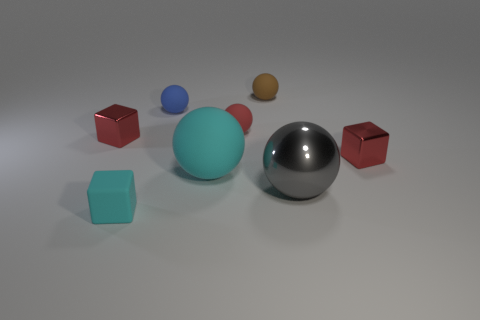How many things are both behind the red ball and in front of the big gray sphere?
Provide a succinct answer. 0. How many matte objects are tiny things or small brown things?
Ensure brevity in your answer.  4. There is a gray metallic ball that is in front of the cyan sphere that is in front of the brown object; what size is it?
Your response must be concise. Large. What material is the tiny thing that is the same color as the large matte sphere?
Provide a succinct answer. Rubber. Are there any small blue balls that are behind the red shiny cube right of the tiny red metal cube that is on the left side of the cyan rubber cube?
Keep it short and to the point. Yes. Does the cube to the right of the tiny red sphere have the same material as the large thing that is on the left side of the tiny brown matte sphere?
Give a very brief answer. No. How many objects are tiny cyan objects or small rubber things to the left of the blue thing?
Your response must be concise. 1. How many other small matte things have the same shape as the small blue thing?
Provide a succinct answer. 2. There is a cyan ball that is the same size as the gray shiny sphere; what material is it?
Make the answer very short. Rubber. How big is the metallic object that is in front of the red object that is in front of the shiny object left of the tiny brown thing?
Make the answer very short. Large. 